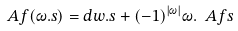<formula> <loc_0><loc_0><loc_500><loc_500>\ A f ( \omega . s ) = d w . s + ( - 1 ) ^ { | \omega | } \omega . \ A f s</formula> 